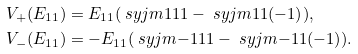Convert formula to latex. <formula><loc_0><loc_0><loc_500><loc_500>V _ { + } ( E _ { 1 1 } ) & = E _ { 1 1 } ( \ s y j m { 1 } { 1 1 } - \ s y j m { 1 } { 1 ( - 1 ) } ) , \\ V _ { - } ( E _ { 1 1 } ) & = - E _ { 1 1 } ( \ s y j m { - 1 } { 1 1 } - \ s y j m { - 1 } { 1 ( - 1 ) } ) .</formula> 